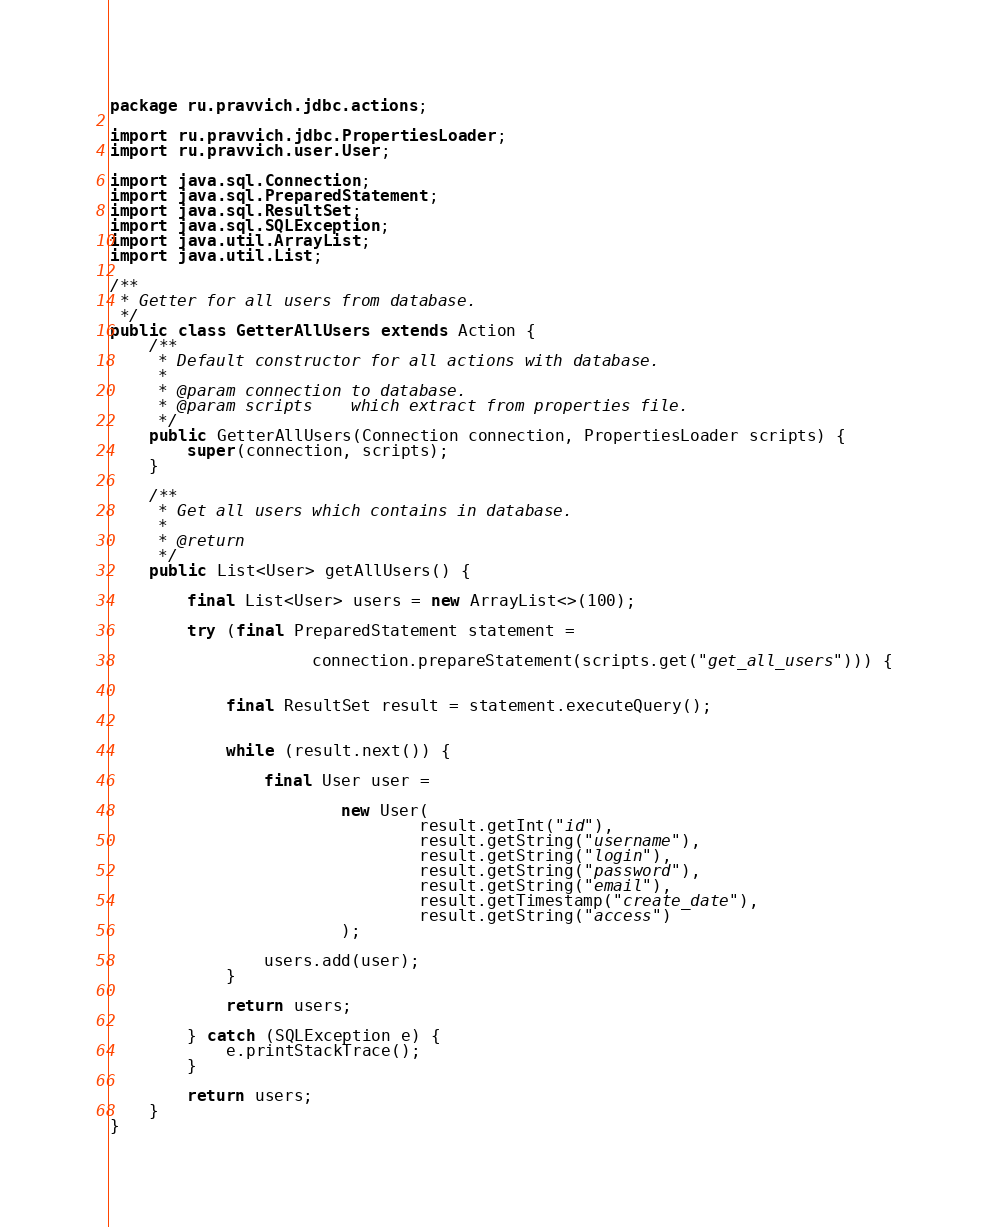Convert code to text. <code><loc_0><loc_0><loc_500><loc_500><_Java_>package ru.pravvich.jdbc.actions;

import ru.pravvich.jdbc.PropertiesLoader;
import ru.pravvich.user.User;

import java.sql.Connection;
import java.sql.PreparedStatement;
import java.sql.ResultSet;
import java.sql.SQLException;
import java.util.ArrayList;
import java.util.List;

/**
 * Getter for all users from database.
 */
public class GetterAllUsers extends Action {
    /**
     * Default constructor for all actions with database.
     *
     * @param connection to database.
     * @param scripts    which extract from properties file.
     */
    public GetterAllUsers(Connection connection, PropertiesLoader scripts) {
        super(connection, scripts);
    }

    /**
     * Get all users which contains in database.
     *
     * @return
     */
    public List<User> getAllUsers() {

        final List<User> users = new ArrayList<>(100);

        try (final PreparedStatement statement =

                     connection.prepareStatement(scripts.get("get_all_users"))) {


            final ResultSet result = statement.executeQuery();


            while (result.next()) {

                final User user =

                        new User(
                                result.getInt("id"),
                                result.getString("username"),
                                result.getString("login"),
                                result.getString("password"),
                                result.getString("email"),
                                result.getTimestamp("create_date"),
                                result.getString("access")
                        );

                users.add(user);
            }

            return users;

        } catch (SQLException e) {
            e.printStackTrace();
        }

        return users;
    }
}
</code> 